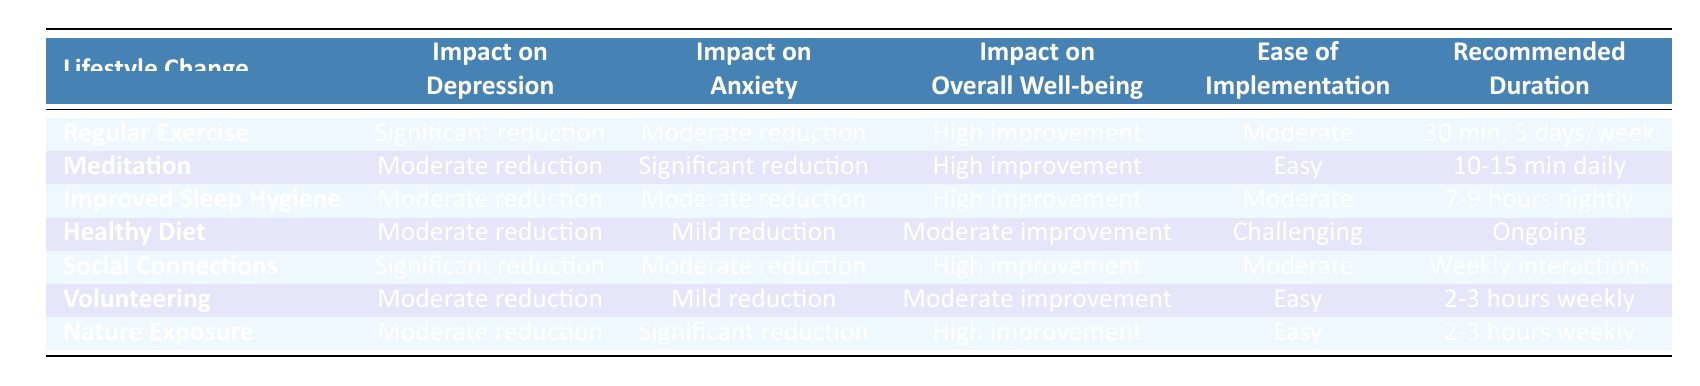What lifestyle change has a significant reduction in depression? Regular Exercise and Social Connections both show significant reduction in depression.
Answer: Regular Exercise, Social Connections Which lifestyle change shows the highest improvement in overall well-being? Regular Exercise, Meditation, Social Connections, and Nature Exposure all indicate high improvement in overall well-being.
Answer: Regular Exercise, Meditation, Social Connections, Nature Exposure Is Healthy Diet easy to implement? The table indicates that Healthy Diet has an ease of implementation categorized as challenging.
Answer: No What is the average impact on anxiety among all lifestyle changes? The impact on anxiety values from the table are Moderate, Significant, Moderate, Mild, Moderate, Mild, and Significant. Calculating the average, we categorize them as 3 Moderates, 3 Milds, and 2 Significants. This results in a balanced evaluation leaning towards Moderate overall.
Answer: Moderate Which lifestyle change has the recommended duration of 10-15 minutes daily? By checking the table, Meditation is the only lifestyle change that specifies a duration of 10-15 minutes daily.
Answer: Meditation Does Improved Sleep Hygiene have a higher impact on anxiety compared to Healthy Diet? Improved Sleep Hygiene shows Moderate reduction in anxiety while Healthy Diet shows Mild reduction in anxiety. Since Moderate is a higher impact than Mild, the answer is yes.
Answer: Yes What is the difference in ease of implementation between Meditation and Healthy Diet? Meditation is categorized as Easy while Healthy Diet is categorized as Challenging. Thus, the difference in ease of implementation is that one is easy while the other is challenging.
Answer: Easy to Challenging Which lifestyle change requires weekly interactions? Reviewing the table shows that Social Connections is the only lifestyle change requiring weekly interactions for its recommended duration.
Answer: Social Connections What is the combined impact on both depression and anxiety for Nature Exposure? Nature Exposure shows a Moderate reduction in depression and a Significant reduction in anxiety. To evaluate the combined impact, we can consider the higher impact (Significant) as the dominant effect, thus indicating a positive result overall.
Answer: Significant reduction in Anxiety, Moderate reduction in Depression 